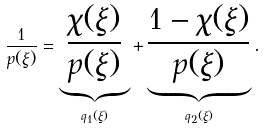<formula> <loc_0><loc_0><loc_500><loc_500>\frac { 1 } { p ( \xi ) } = \underbrace { \frac { \chi ( \xi ) } { p ( \xi ) } } _ { q _ { 1 } ( \xi ) } + \underbrace { \frac { 1 - \chi ( \xi ) } { p ( \xi ) } } _ { q _ { 2 } ( \xi ) } .</formula> 